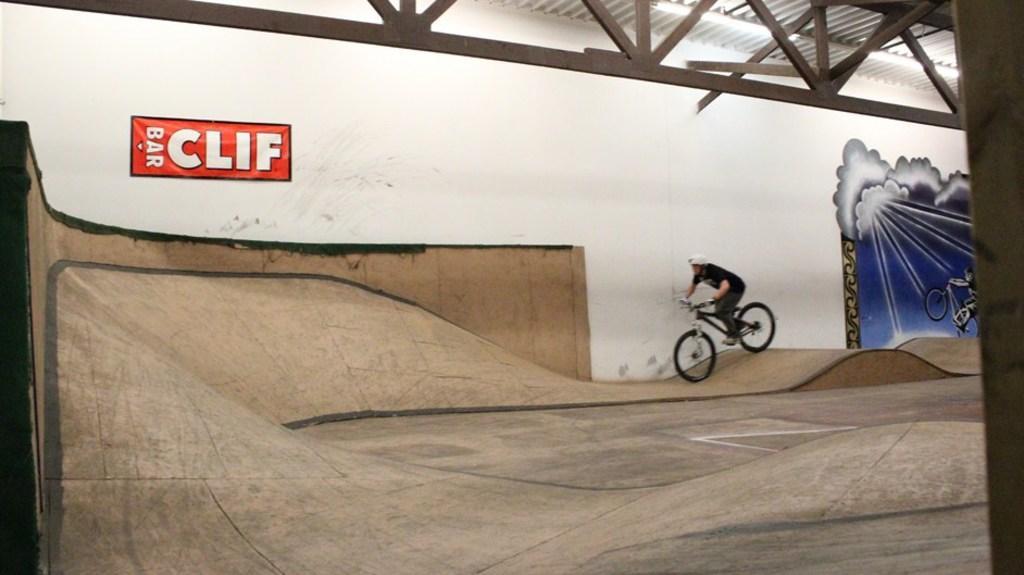Please provide a concise description of this image. In this image we can see a person riding bicycle on the path, grills, electric lights, shed and paintings on the wall. 